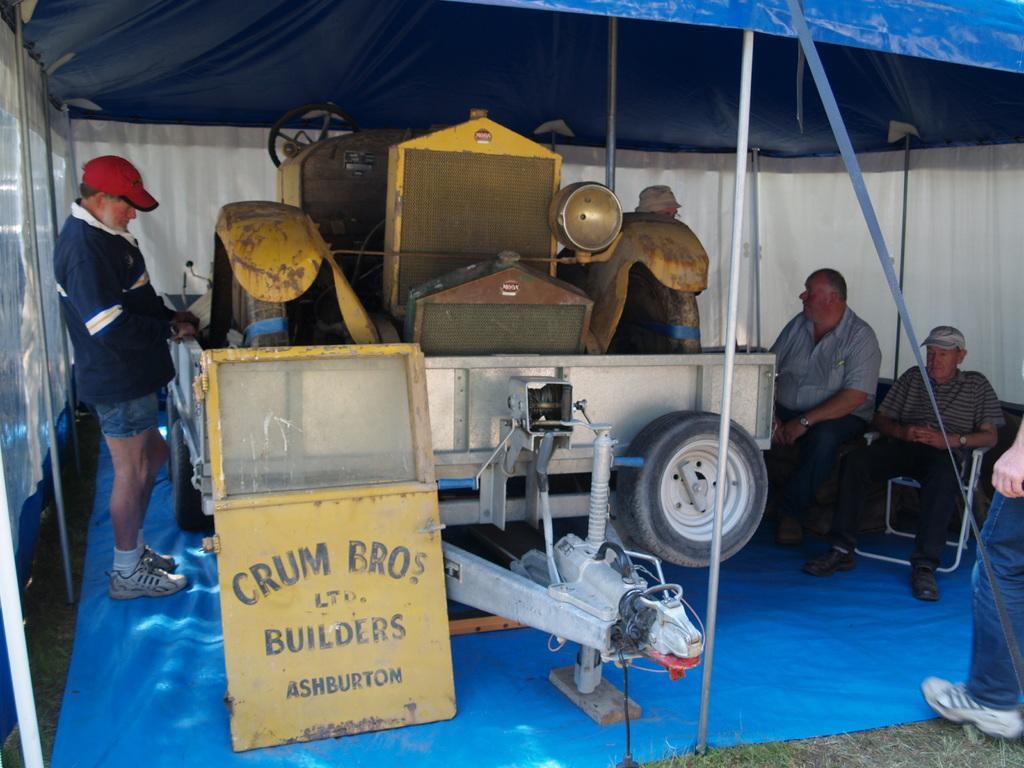How would you summarize this image in a sentence or two? Here in this picture we can see a trolley with some equipment present on it, that is present on the ground and we can see a mat on the ground and we can see the ground is covered with grass and we can see some people are sitting on chairs and some are standing and some people are wearing caps and in the front we can see a door of a vehicle present and above them we can see a tent present. 